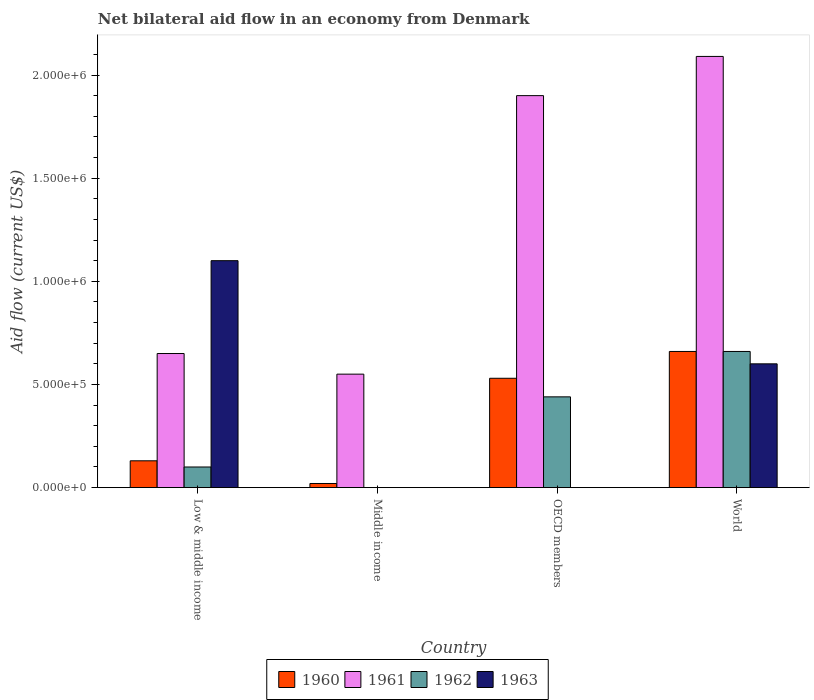Are the number of bars per tick equal to the number of legend labels?
Ensure brevity in your answer.  No. How many bars are there on the 4th tick from the right?
Provide a short and direct response. 4. What is the label of the 3rd group of bars from the left?
Make the answer very short. OECD members. In how many cases, is the number of bars for a given country not equal to the number of legend labels?
Your response must be concise. 2. What is the net bilateral aid flow in 1961 in World?
Keep it short and to the point. 2.09e+06. Across all countries, what is the maximum net bilateral aid flow in 1963?
Keep it short and to the point. 1.10e+06. What is the total net bilateral aid flow in 1960 in the graph?
Ensure brevity in your answer.  1.34e+06. What is the difference between the net bilateral aid flow in 1961 in Low & middle income and that in World?
Your response must be concise. -1.44e+06. What is the difference between the net bilateral aid flow in 1960 in Low & middle income and the net bilateral aid flow in 1961 in World?
Keep it short and to the point. -1.96e+06. What is the average net bilateral aid flow in 1961 per country?
Ensure brevity in your answer.  1.30e+06. What is the difference between the net bilateral aid flow of/in 1961 and net bilateral aid flow of/in 1962 in OECD members?
Provide a succinct answer. 1.46e+06. In how many countries, is the net bilateral aid flow in 1962 greater than 1400000 US$?
Ensure brevity in your answer.  0. What is the ratio of the net bilateral aid flow in 1960 in Low & middle income to that in World?
Your answer should be compact. 0.2. Is the net bilateral aid flow in 1963 in Low & middle income less than that in World?
Your response must be concise. No. Is the difference between the net bilateral aid flow in 1961 in OECD members and World greater than the difference between the net bilateral aid flow in 1962 in OECD members and World?
Give a very brief answer. Yes. What is the difference between the highest and the second highest net bilateral aid flow in 1960?
Offer a terse response. 1.30e+05. What is the difference between the highest and the lowest net bilateral aid flow in 1960?
Provide a short and direct response. 6.40e+05. Is it the case that in every country, the sum of the net bilateral aid flow in 1962 and net bilateral aid flow in 1961 is greater than the sum of net bilateral aid flow in 1963 and net bilateral aid flow in 1960?
Your answer should be compact. No. How many bars are there?
Offer a very short reply. 13. How many countries are there in the graph?
Provide a short and direct response. 4. Where does the legend appear in the graph?
Your answer should be very brief. Bottom center. How many legend labels are there?
Your answer should be compact. 4. What is the title of the graph?
Your answer should be very brief. Net bilateral aid flow in an economy from Denmark. Does "1968" appear as one of the legend labels in the graph?
Your response must be concise. No. What is the label or title of the Y-axis?
Keep it short and to the point. Aid flow (current US$). What is the Aid flow (current US$) of 1961 in Low & middle income?
Your answer should be very brief. 6.50e+05. What is the Aid flow (current US$) in 1962 in Low & middle income?
Provide a short and direct response. 1.00e+05. What is the Aid flow (current US$) in 1963 in Low & middle income?
Provide a succinct answer. 1.10e+06. What is the Aid flow (current US$) in 1960 in Middle income?
Keep it short and to the point. 2.00e+04. What is the Aid flow (current US$) of 1960 in OECD members?
Make the answer very short. 5.30e+05. What is the Aid flow (current US$) in 1961 in OECD members?
Ensure brevity in your answer.  1.90e+06. What is the Aid flow (current US$) of 1963 in OECD members?
Provide a succinct answer. 0. What is the Aid flow (current US$) in 1960 in World?
Give a very brief answer. 6.60e+05. What is the Aid flow (current US$) in 1961 in World?
Offer a very short reply. 2.09e+06. What is the Aid flow (current US$) in 1963 in World?
Offer a terse response. 6.00e+05. Across all countries, what is the maximum Aid flow (current US$) in 1960?
Your response must be concise. 6.60e+05. Across all countries, what is the maximum Aid flow (current US$) in 1961?
Offer a very short reply. 2.09e+06. Across all countries, what is the maximum Aid flow (current US$) in 1962?
Ensure brevity in your answer.  6.60e+05. Across all countries, what is the maximum Aid flow (current US$) of 1963?
Offer a terse response. 1.10e+06. Across all countries, what is the minimum Aid flow (current US$) in 1960?
Your response must be concise. 2.00e+04. What is the total Aid flow (current US$) of 1960 in the graph?
Give a very brief answer. 1.34e+06. What is the total Aid flow (current US$) of 1961 in the graph?
Ensure brevity in your answer.  5.19e+06. What is the total Aid flow (current US$) of 1962 in the graph?
Offer a very short reply. 1.20e+06. What is the total Aid flow (current US$) of 1963 in the graph?
Your answer should be compact. 1.70e+06. What is the difference between the Aid flow (current US$) in 1961 in Low & middle income and that in Middle income?
Give a very brief answer. 1.00e+05. What is the difference between the Aid flow (current US$) in 1960 in Low & middle income and that in OECD members?
Your response must be concise. -4.00e+05. What is the difference between the Aid flow (current US$) in 1961 in Low & middle income and that in OECD members?
Keep it short and to the point. -1.25e+06. What is the difference between the Aid flow (current US$) in 1962 in Low & middle income and that in OECD members?
Keep it short and to the point. -3.40e+05. What is the difference between the Aid flow (current US$) of 1960 in Low & middle income and that in World?
Offer a terse response. -5.30e+05. What is the difference between the Aid flow (current US$) of 1961 in Low & middle income and that in World?
Your response must be concise. -1.44e+06. What is the difference between the Aid flow (current US$) in 1962 in Low & middle income and that in World?
Provide a succinct answer. -5.60e+05. What is the difference between the Aid flow (current US$) of 1963 in Low & middle income and that in World?
Provide a short and direct response. 5.00e+05. What is the difference between the Aid flow (current US$) in 1960 in Middle income and that in OECD members?
Your answer should be very brief. -5.10e+05. What is the difference between the Aid flow (current US$) in 1961 in Middle income and that in OECD members?
Provide a short and direct response. -1.35e+06. What is the difference between the Aid flow (current US$) of 1960 in Middle income and that in World?
Ensure brevity in your answer.  -6.40e+05. What is the difference between the Aid flow (current US$) in 1961 in Middle income and that in World?
Ensure brevity in your answer.  -1.54e+06. What is the difference between the Aid flow (current US$) in 1960 in OECD members and that in World?
Your answer should be very brief. -1.30e+05. What is the difference between the Aid flow (current US$) in 1962 in OECD members and that in World?
Your answer should be compact. -2.20e+05. What is the difference between the Aid flow (current US$) in 1960 in Low & middle income and the Aid flow (current US$) in 1961 in Middle income?
Your answer should be very brief. -4.20e+05. What is the difference between the Aid flow (current US$) in 1960 in Low & middle income and the Aid flow (current US$) in 1961 in OECD members?
Provide a short and direct response. -1.77e+06. What is the difference between the Aid flow (current US$) in 1960 in Low & middle income and the Aid flow (current US$) in 1962 in OECD members?
Your response must be concise. -3.10e+05. What is the difference between the Aid flow (current US$) in 1961 in Low & middle income and the Aid flow (current US$) in 1962 in OECD members?
Your answer should be very brief. 2.10e+05. What is the difference between the Aid flow (current US$) in 1960 in Low & middle income and the Aid flow (current US$) in 1961 in World?
Provide a short and direct response. -1.96e+06. What is the difference between the Aid flow (current US$) of 1960 in Low & middle income and the Aid flow (current US$) of 1962 in World?
Provide a short and direct response. -5.30e+05. What is the difference between the Aid flow (current US$) of 1960 in Low & middle income and the Aid flow (current US$) of 1963 in World?
Offer a very short reply. -4.70e+05. What is the difference between the Aid flow (current US$) in 1961 in Low & middle income and the Aid flow (current US$) in 1963 in World?
Provide a short and direct response. 5.00e+04. What is the difference between the Aid flow (current US$) of 1962 in Low & middle income and the Aid flow (current US$) of 1963 in World?
Make the answer very short. -5.00e+05. What is the difference between the Aid flow (current US$) in 1960 in Middle income and the Aid flow (current US$) in 1961 in OECD members?
Provide a succinct answer. -1.88e+06. What is the difference between the Aid flow (current US$) of 1960 in Middle income and the Aid flow (current US$) of 1962 in OECD members?
Offer a very short reply. -4.20e+05. What is the difference between the Aid flow (current US$) in 1960 in Middle income and the Aid flow (current US$) in 1961 in World?
Your answer should be very brief. -2.07e+06. What is the difference between the Aid flow (current US$) of 1960 in Middle income and the Aid flow (current US$) of 1962 in World?
Make the answer very short. -6.40e+05. What is the difference between the Aid flow (current US$) of 1960 in Middle income and the Aid flow (current US$) of 1963 in World?
Make the answer very short. -5.80e+05. What is the difference between the Aid flow (current US$) of 1961 in Middle income and the Aid flow (current US$) of 1962 in World?
Provide a short and direct response. -1.10e+05. What is the difference between the Aid flow (current US$) in 1960 in OECD members and the Aid flow (current US$) in 1961 in World?
Provide a succinct answer. -1.56e+06. What is the difference between the Aid flow (current US$) of 1960 in OECD members and the Aid flow (current US$) of 1962 in World?
Provide a succinct answer. -1.30e+05. What is the difference between the Aid flow (current US$) of 1961 in OECD members and the Aid flow (current US$) of 1962 in World?
Your answer should be very brief. 1.24e+06. What is the difference between the Aid flow (current US$) of 1961 in OECD members and the Aid flow (current US$) of 1963 in World?
Your response must be concise. 1.30e+06. What is the difference between the Aid flow (current US$) in 1962 in OECD members and the Aid flow (current US$) in 1963 in World?
Your answer should be compact. -1.60e+05. What is the average Aid flow (current US$) of 1960 per country?
Offer a very short reply. 3.35e+05. What is the average Aid flow (current US$) in 1961 per country?
Your answer should be very brief. 1.30e+06. What is the average Aid flow (current US$) of 1962 per country?
Keep it short and to the point. 3.00e+05. What is the average Aid flow (current US$) of 1963 per country?
Keep it short and to the point. 4.25e+05. What is the difference between the Aid flow (current US$) in 1960 and Aid flow (current US$) in 1961 in Low & middle income?
Provide a succinct answer. -5.20e+05. What is the difference between the Aid flow (current US$) in 1960 and Aid flow (current US$) in 1962 in Low & middle income?
Keep it short and to the point. 3.00e+04. What is the difference between the Aid flow (current US$) in 1960 and Aid flow (current US$) in 1963 in Low & middle income?
Your answer should be very brief. -9.70e+05. What is the difference between the Aid flow (current US$) in 1961 and Aid flow (current US$) in 1962 in Low & middle income?
Provide a succinct answer. 5.50e+05. What is the difference between the Aid flow (current US$) in 1961 and Aid flow (current US$) in 1963 in Low & middle income?
Your answer should be very brief. -4.50e+05. What is the difference between the Aid flow (current US$) of 1962 and Aid flow (current US$) of 1963 in Low & middle income?
Provide a short and direct response. -1.00e+06. What is the difference between the Aid flow (current US$) of 1960 and Aid flow (current US$) of 1961 in Middle income?
Offer a terse response. -5.30e+05. What is the difference between the Aid flow (current US$) in 1960 and Aid flow (current US$) in 1961 in OECD members?
Provide a short and direct response. -1.37e+06. What is the difference between the Aid flow (current US$) of 1961 and Aid flow (current US$) of 1962 in OECD members?
Ensure brevity in your answer.  1.46e+06. What is the difference between the Aid flow (current US$) of 1960 and Aid flow (current US$) of 1961 in World?
Make the answer very short. -1.43e+06. What is the difference between the Aid flow (current US$) of 1960 and Aid flow (current US$) of 1962 in World?
Give a very brief answer. 0. What is the difference between the Aid flow (current US$) in 1961 and Aid flow (current US$) in 1962 in World?
Offer a very short reply. 1.43e+06. What is the difference between the Aid flow (current US$) of 1961 and Aid flow (current US$) of 1963 in World?
Provide a short and direct response. 1.49e+06. What is the ratio of the Aid flow (current US$) in 1961 in Low & middle income to that in Middle income?
Your response must be concise. 1.18. What is the ratio of the Aid flow (current US$) in 1960 in Low & middle income to that in OECD members?
Provide a short and direct response. 0.25. What is the ratio of the Aid flow (current US$) in 1961 in Low & middle income to that in OECD members?
Your response must be concise. 0.34. What is the ratio of the Aid flow (current US$) of 1962 in Low & middle income to that in OECD members?
Offer a terse response. 0.23. What is the ratio of the Aid flow (current US$) of 1960 in Low & middle income to that in World?
Give a very brief answer. 0.2. What is the ratio of the Aid flow (current US$) of 1961 in Low & middle income to that in World?
Offer a terse response. 0.31. What is the ratio of the Aid flow (current US$) of 1962 in Low & middle income to that in World?
Your response must be concise. 0.15. What is the ratio of the Aid flow (current US$) in 1963 in Low & middle income to that in World?
Offer a terse response. 1.83. What is the ratio of the Aid flow (current US$) in 1960 in Middle income to that in OECD members?
Provide a short and direct response. 0.04. What is the ratio of the Aid flow (current US$) of 1961 in Middle income to that in OECD members?
Ensure brevity in your answer.  0.29. What is the ratio of the Aid flow (current US$) in 1960 in Middle income to that in World?
Ensure brevity in your answer.  0.03. What is the ratio of the Aid flow (current US$) in 1961 in Middle income to that in World?
Offer a terse response. 0.26. What is the ratio of the Aid flow (current US$) in 1960 in OECD members to that in World?
Your response must be concise. 0.8. What is the ratio of the Aid flow (current US$) of 1962 in OECD members to that in World?
Provide a short and direct response. 0.67. What is the difference between the highest and the second highest Aid flow (current US$) in 1960?
Provide a short and direct response. 1.30e+05. What is the difference between the highest and the second highest Aid flow (current US$) of 1962?
Make the answer very short. 2.20e+05. What is the difference between the highest and the lowest Aid flow (current US$) in 1960?
Your answer should be compact. 6.40e+05. What is the difference between the highest and the lowest Aid flow (current US$) in 1961?
Give a very brief answer. 1.54e+06. What is the difference between the highest and the lowest Aid flow (current US$) in 1962?
Give a very brief answer. 6.60e+05. What is the difference between the highest and the lowest Aid flow (current US$) in 1963?
Provide a short and direct response. 1.10e+06. 